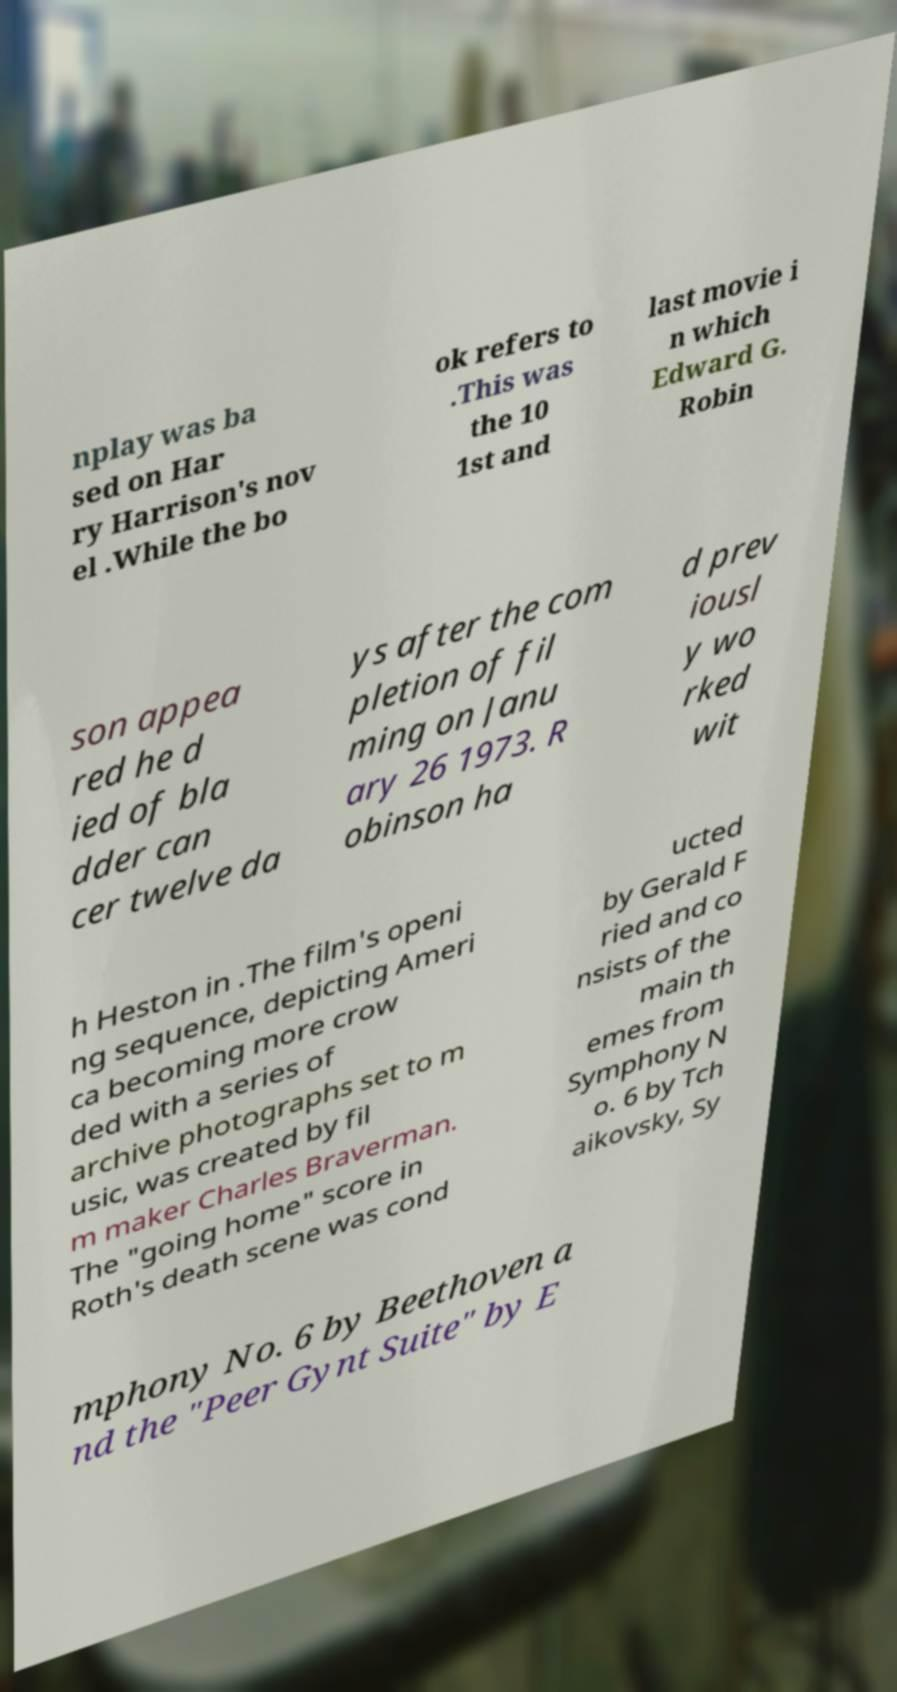For documentation purposes, I need the text within this image transcribed. Could you provide that? nplay was ba sed on Har ry Harrison's nov el .While the bo ok refers to .This was the 10 1st and last movie i n which Edward G. Robin son appea red he d ied of bla dder can cer twelve da ys after the com pletion of fil ming on Janu ary 26 1973. R obinson ha d prev iousl y wo rked wit h Heston in .The film's openi ng sequence, depicting Ameri ca becoming more crow ded with a series of archive photographs set to m usic, was created by fil m maker Charles Braverman. The "going home" score in Roth's death scene was cond ucted by Gerald F ried and co nsists of the main th emes from Symphony N o. 6 by Tch aikovsky, Sy mphony No. 6 by Beethoven a nd the "Peer Gynt Suite" by E 